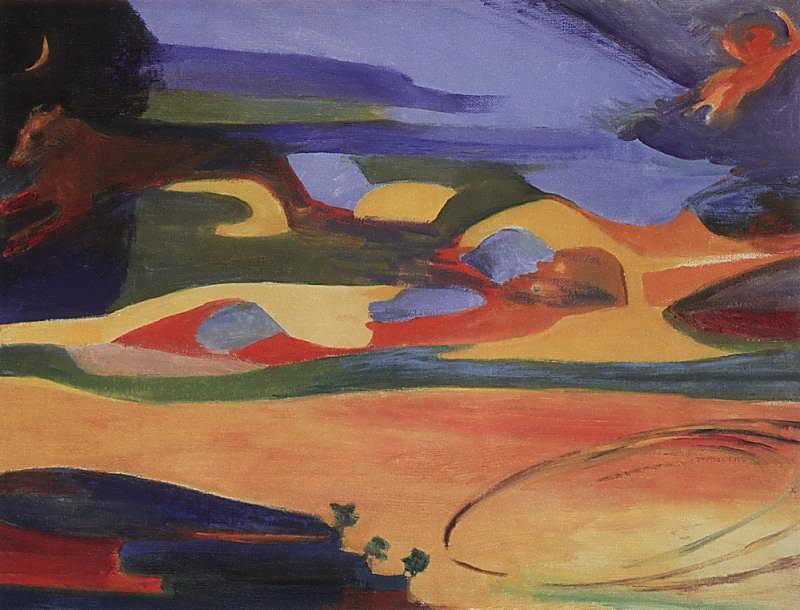Imagine this painting is the backdrop of an animated movie. What could the plot be? In an enchanted land where colors come to life, a young artist finds her way into this magical landscape. The plot follows her journey as she interacts with the living colors, each representing a different emotion or element of nature. Along the way, she befriends a spirited animal who guides her through various challenges, teaching her about the importance of balance and harmony in life. The backdrop, ever-changing with her emotions, reflects the trials and triumphs she encounters. In the climax, a mighty storm of colors threatens to unsettle the harmony of the land, and the artist must use her newfound wisdom to restore peace. What role do you think the leaping animal plays? The leaping animal could be the guardian of the enchanted land, acting as both a guide and protector for the young artist. Its dynamic nature symbolizes the ever-present potential for change and growth, and its leap could represent the courage to embrace the unknown. The animal's role would be pivotal, helping the protagonist navigate through the landscape and understand the deeper connections between all forms of life. Write a detailed scene where the protagonist paints something new in the landscape. As the sun began to set, casting a golden glow over the landscape, the young artist stood at the edge of a tranquil body of water. In her hands was a brush imbued with the essence of the land itself. She dipped it into the vibrant palette of the world around her, capturing the reds of the hills, the blues of the sky, and the greens of the trees. With a deep breath, she began to paint—a magnificent tree whose branches reached toward the heavens, its leaves shimmering with every hue imaginable. As her brush danced across an invisible canvas, the tree sprang to life, growing and blossoming right before her eyes. The air seemed to hum with a new energy, the newly created tree blending seamlessly into the landscape. It stood as a testament to her growth and the newfound harmony she had discovered, a living symbol of the interconnectedness of all things in this magical world. What if the painting depicted a futuristic city instead of a natural landscape? How would the image change? If the painting depicted a futuristic city, the canvas would likely be dominated by sleek, metallic structures and vibrant neon lights. The natural elements would be replaced by towering skyscrapers, hover vehicles zipping through the sky, and advanced technologies integrated into every aspect of the city. The color palette would shift to include more blues, silvers, and purples, giving the scene an otherworldly glow. The leaping animal could transform into a robotic creature, symbolizing the fusion of nature and technology. The sky might feature digital constellations and holographic displays, adding to the futuristic ambiance of the cityscape. This transformation would convey a vision of progress and innovation, highlighting humanity's journey into the future while still maintaining a sense of wonder and exploration. 